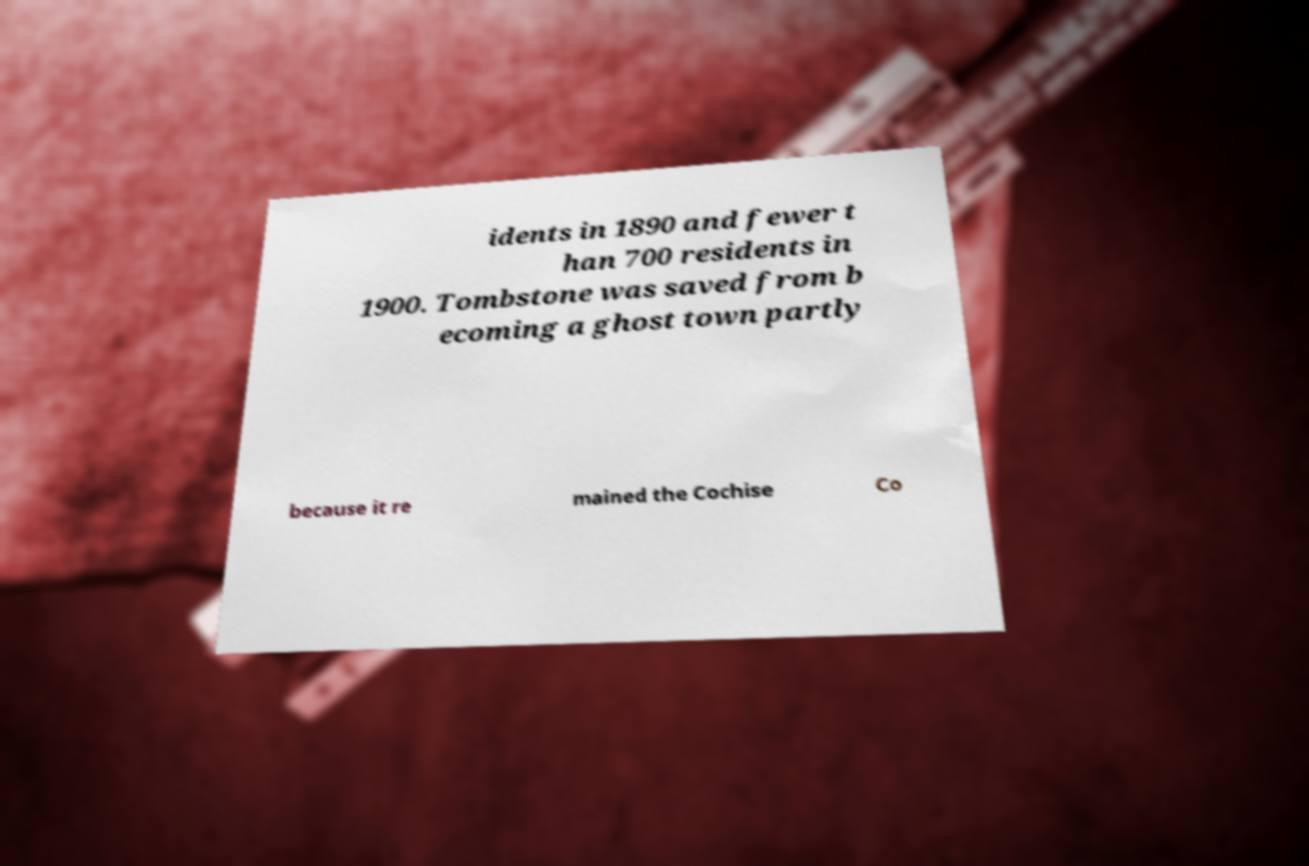For documentation purposes, I need the text within this image transcribed. Could you provide that? idents in 1890 and fewer t han 700 residents in 1900. Tombstone was saved from b ecoming a ghost town partly because it re mained the Cochise Co 